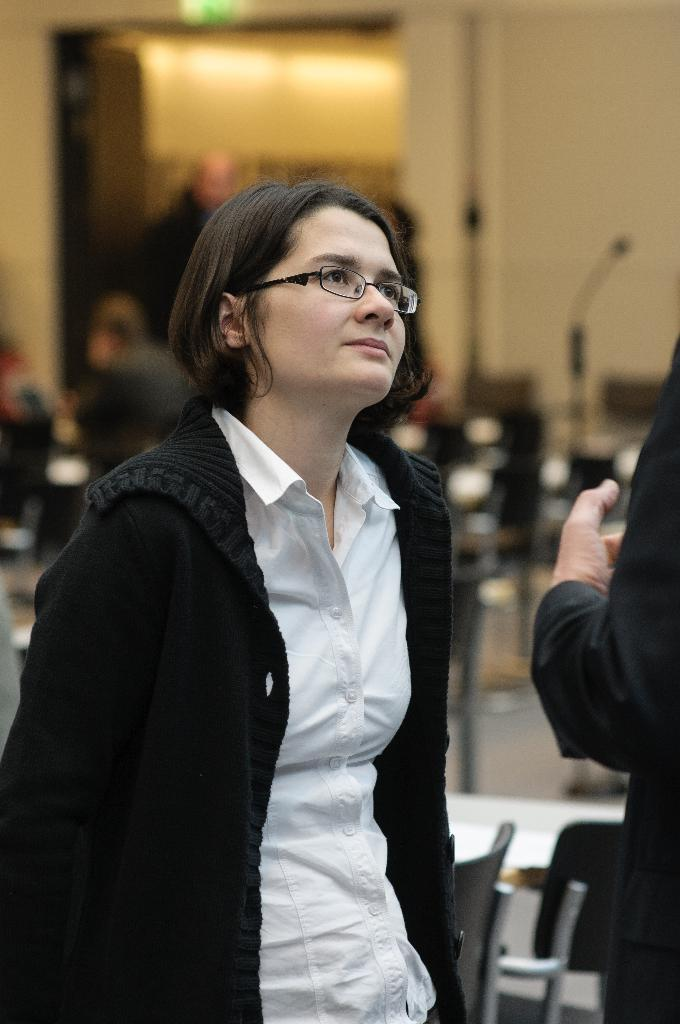What is the primary subject of the image? There is a woman standing in the image. Can you describe the other person in the image? There is another person in the image, but their specific characteristics are not mentioned in the facts. What type of furniture can be seen in the background of the image? There are chairs and tables in the background of the image. What else is visible in the background of the image? There is a group of people and a door in the background of the image. What type of match is being played in the image? There is no match being played in the image; it features a woman standing and other people in the background. What is the relationship between the woman and the group of people in the background? The facts do not provide any information about the relationship between the woman and the group of people in the background. 